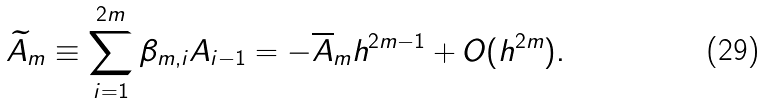<formula> <loc_0><loc_0><loc_500><loc_500>\widetilde { A } _ { m } \equiv \sum _ { i = 1 } ^ { 2 m } \beta _ { m , i } A _ { i - 1 } = - \overline { A } _ { m } h ^ { 2 m - 1 } + O ( h ^ { 2 m } ) .</formula> 